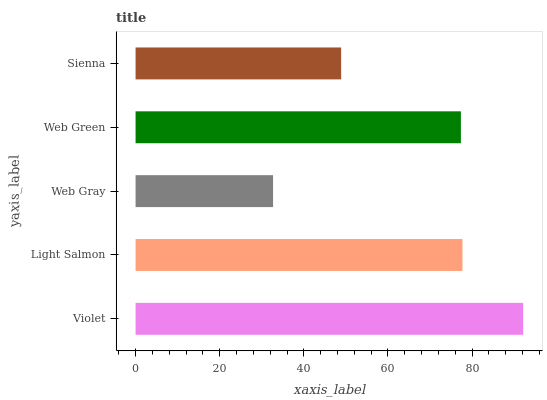Is Web Gray the minimum?
Answer yes or no. Yes. Is Violet the maximum?
Answer yes or no. Yes. Is Light Salmon the minimum?
Answer yes or no. No. Is Light Salmon the maximum?
Answer yes or no. No. Is Violet greater than Light Salmon?
Answer yes or no. Yes. Is Light Salmon less than Violet?
Answer yes or no. Yes. Is Light Salmon greater than Violet?
Answer yes or no. No. Is Violet less than Light Salmon?
Answer yes or no. No. Is Web Green the high median?
Answer yes or no. Yes. Is Web Green the low median?
Answer yes or no. Yes. Is Violet the high median?
Answer yes or no. No. Is Light Salmon the low median?
Answer yes or no. No. 